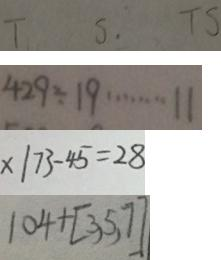Convert formula to latex. <formula><loc_0><loc_0><loc_500><loc_500>T S . T S 
 4 2 9 \div 1 9 \cdots 1 1 
 x \vert 7 3 - 4 5 = 2 8 
 1 0 4 + [ 3 , 5 , 7 ]</formula> 